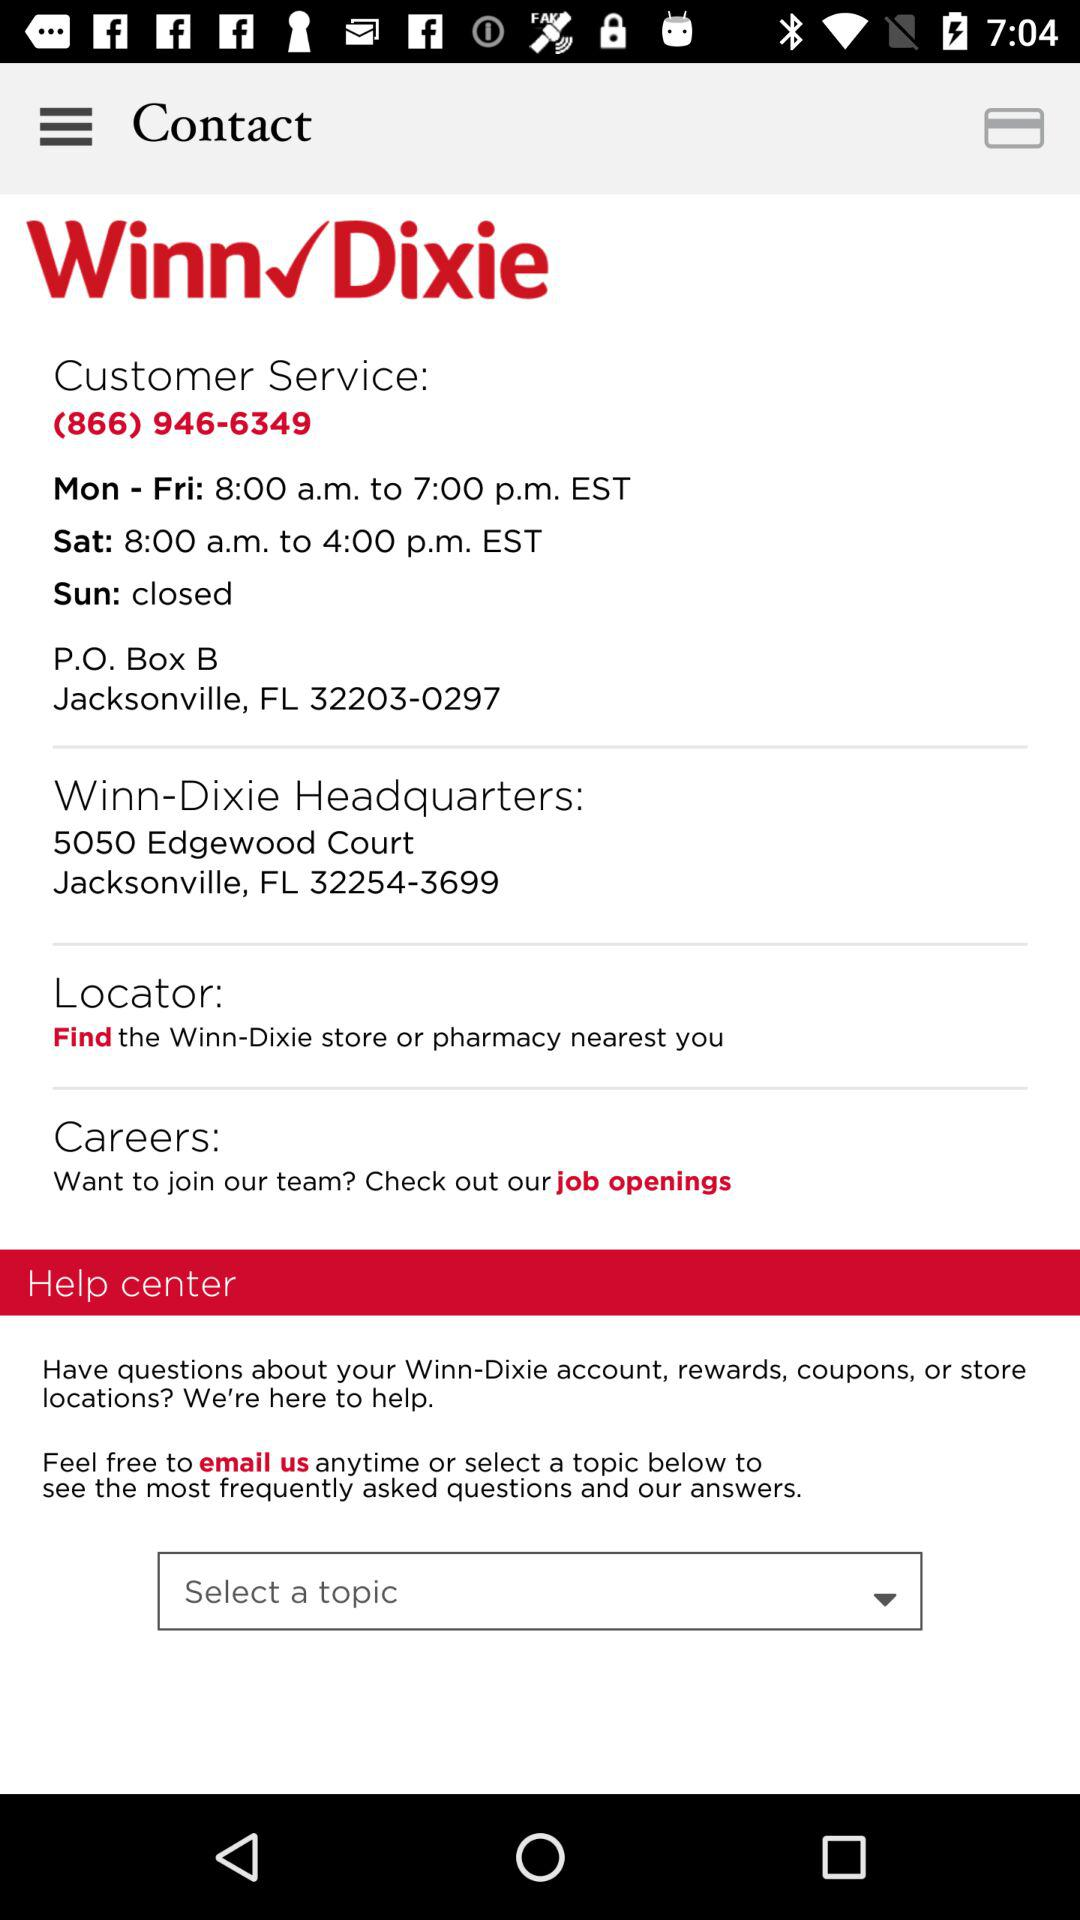What is the contact number for headquarters?
When the provided information is insufficient, respond with <no answer>. <no answer> 